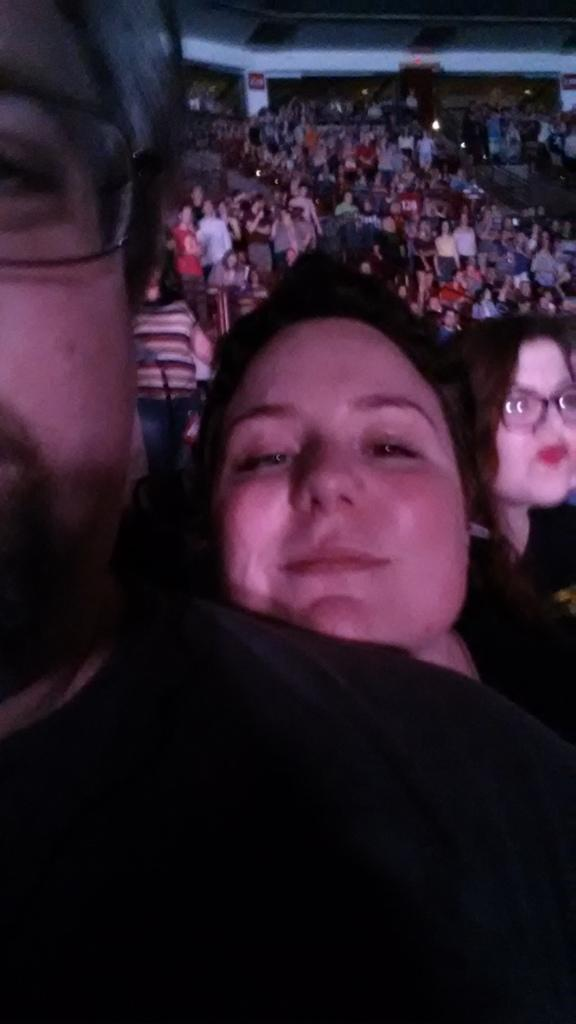What is the main subject of the image? The main subject of the image is a crowd. Are there any specific objects or structures in the image? Yes, there is a pillar and a board in the image. Can you describe the appearance of any individuals in the image? Two people in the front of the image are wearing spectacles. What is the name of the fictional character depicted on the board in the image? There is no fictional character depicted on the board in the image. How many kittens are visible in the image? There are no kittens present in the image. 